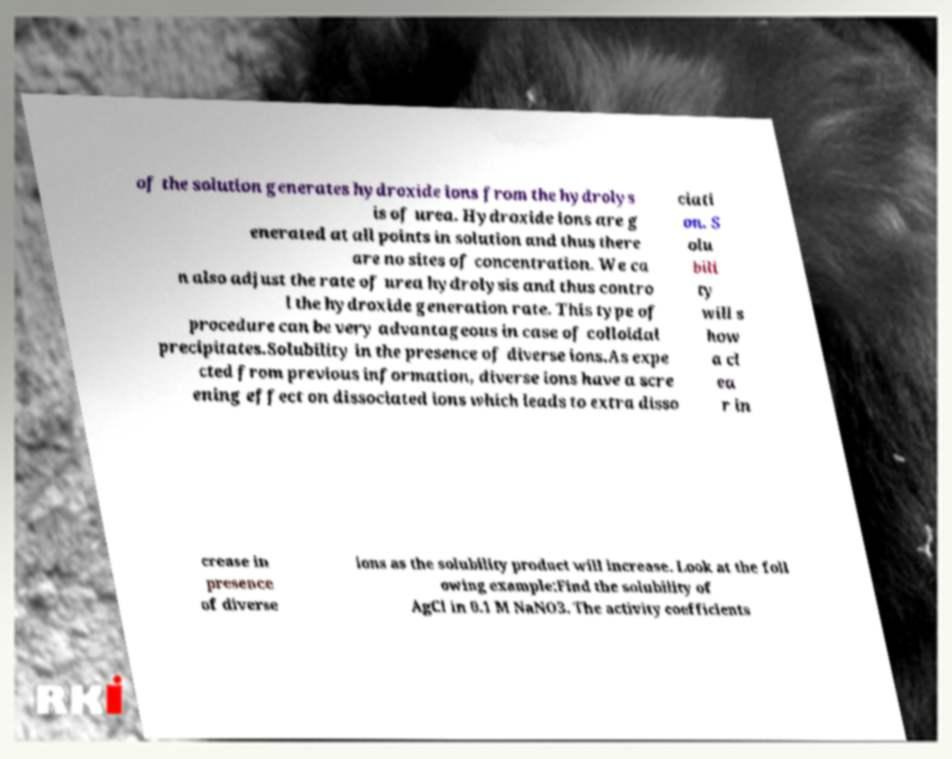Could you assist in decoding the text presented in this image and type it out clearly? of the solution generates hydroxide ions from the hydrolys is of urea. Hydroxide ions are g enerated at all points in solution and thus there are no sites of concentration. We ca n also adjust the rate of urea hydrolysis and thus contro l the hydroxide generation rate. This type of procedure can be very advantageous in case of colloidal precipitates.Solubility in the presence of diverse ions.As expe cted from previous information, diverse ions have a scre ening effect on dissociated ions which leads to extra disso ciati on. S olu bili ty will s how a cl ea r in crease in presence of diverse ions as the solubility product will increase. Look at the foll owing example:Find the solubility of AgCl in 0.1 M NaNO3. The activity coefficients 